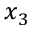Convert formula to latex. <formula><loc_0><loc_0><loc_500><loc_500>x _ { 3 }</formula> 